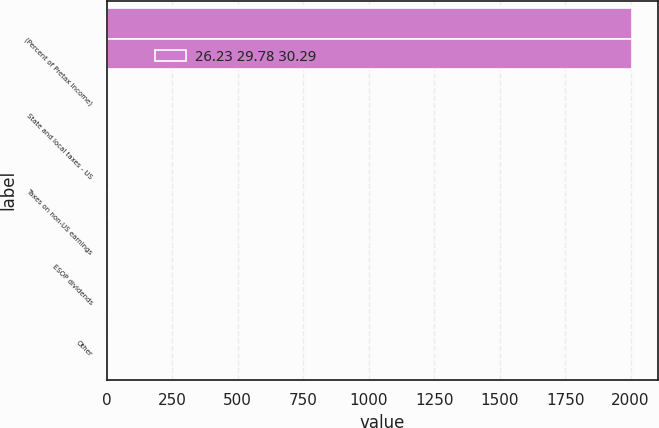Convert chart. <chart><loc_0><loc_0><loc_500><loc_500><stacked_bar_chart><ecel><fcel>(Percent of Pretax Income)<fcel>State and local taxes - US<fcel>Taxes on non-US earnings<fcel>ESOP dividends<fcel>Other<nl><fcel>nan<fcel>2006<fcel>0.75<fcel>2.8<fcel>1.03<fcel>5.69<nl><fcel>26.23 29.78 30.29<fcel>2004<fcel>1.23<fcel>3.56<fcel>1.08<fcel>1.3<nl></chart> 